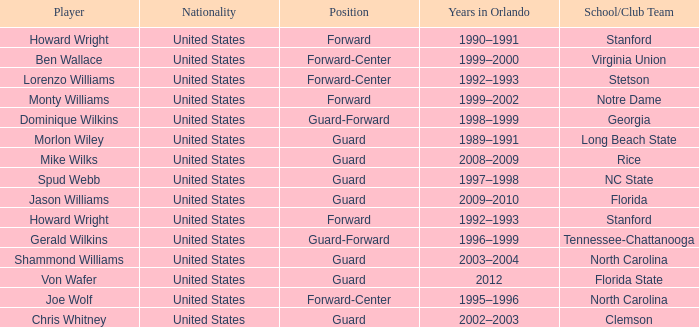What School/Club did Dominique Wilkins play for? Georgia. 